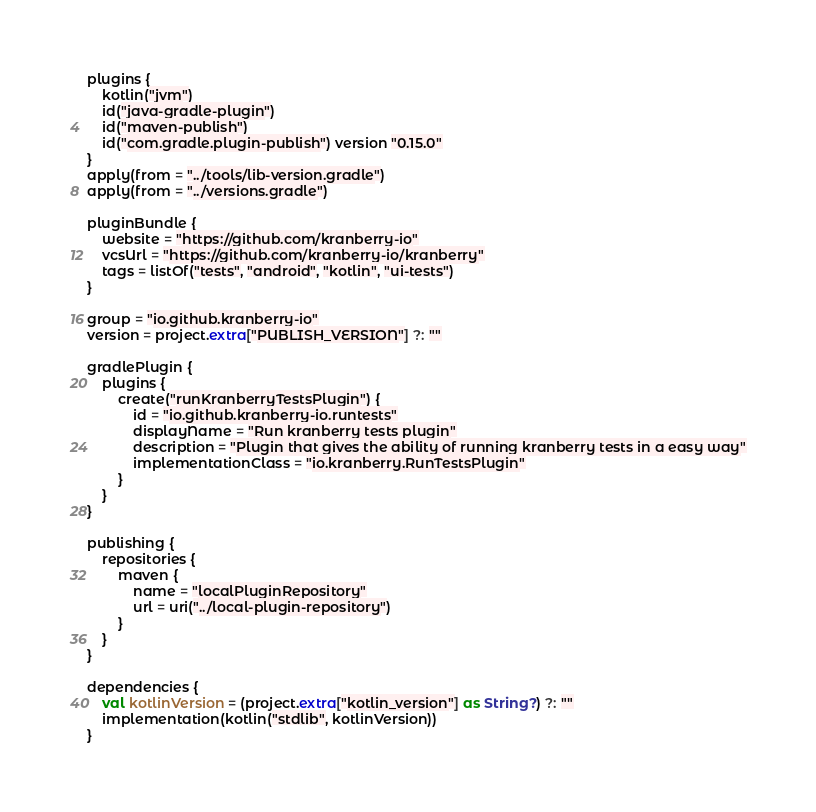<code> <loc_0><loc_0><loc_500><loc_500><_Kotlin_>plugins {
    kotlin("jvm")
    id("java-gradle-plugin")
    id("maven-publish")
    id("com.gradle.plugin-publish") version "0.15.0"
}
apply(from = "../tools/lib-version.gradle")
apply(from = "../versions.gradle")

pluginBundle {
    website = "https://github.com/kranberry-io"
    vcsUrl = "https://github.com/kranberry-io/kranberry"
    tags = listOf("tests", "android", "kotlin", "ui-tests")
}

group = "io.github.kranberry-io"
version = project.extra["PUBLISH_VERSION"] ?: ""

gradlePlugin {
    plugins {
        create("runKranberryTestsPlugin") {
            id = "io.github.kranberry-io.runtests"
            displayName = "Run kranberry tests plugin"
            description = "Plugin that gives the ability of running kranberry tests in a easy way"
            implementationClass = "io.kranberry.RunTestsPlugin"
        }
    }
}

publishing {
    repositories {
        maven {
            name = "localPluginRepository"
            url = uri("../local-plugin-repository")
        }
    }
}

dependencies {
    val kotlinVersion = (project.extra["kotlin_version"] as String?) ?: ""
    implementation(kotlin("stdlib", kotlinVersion))
}</code> 